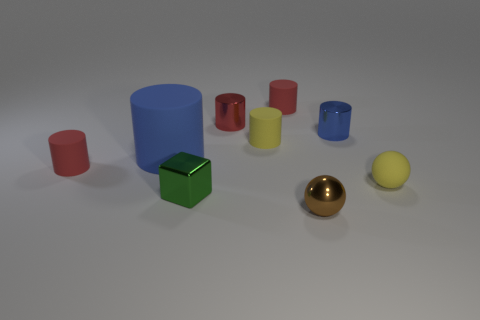There is a blue cylinder that is the same size as the rubber ball; what is its material?
Your answer should be compact. Metal. How many red metal objects are the same shape as the small blue object?
Your answer should be very brief. 1. There is a cylinder that is the same color as the large object; what material is it?
Your response must be concise. Metal. What material is the tiny green block?
Give a very brief answer. Metal. There is a tiny blue thing that is the same shape as the big blue rubber object; what is it made of?
Ensure brevity in your answer.  Metal. Is the number of tiny metal objects to the right of the metal cube the same as the number of things that are in front of the red shiny cylinder?
Provide a short and direct response. No. There is a tiny object that is both in front of the small blue metal cylinder and right of the small brown object; what color is it?
Offer a very short reply. Yellow. Are there any other things that are the same size as the blue matte cylinder?
Offer a very short reply. No. Is the number of blue things that are right of the cube greater than the number of tiny yellow things behind the blue metal object?
Keep it short and to the point. Yes. There is a yellow rubber object that is left of the rubber ball; does it have the same size as the tiny brown thing?
Your response must be concise. Yes. 